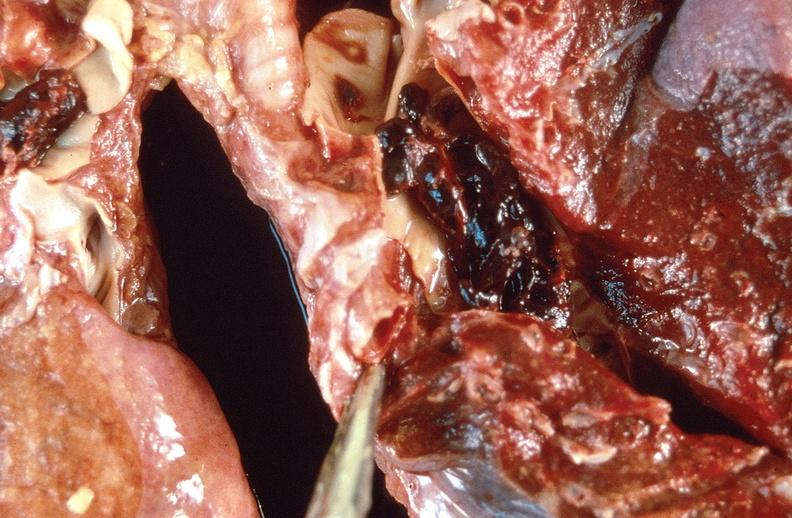where is this?
Answer the question using a single word or phrase. Lung 